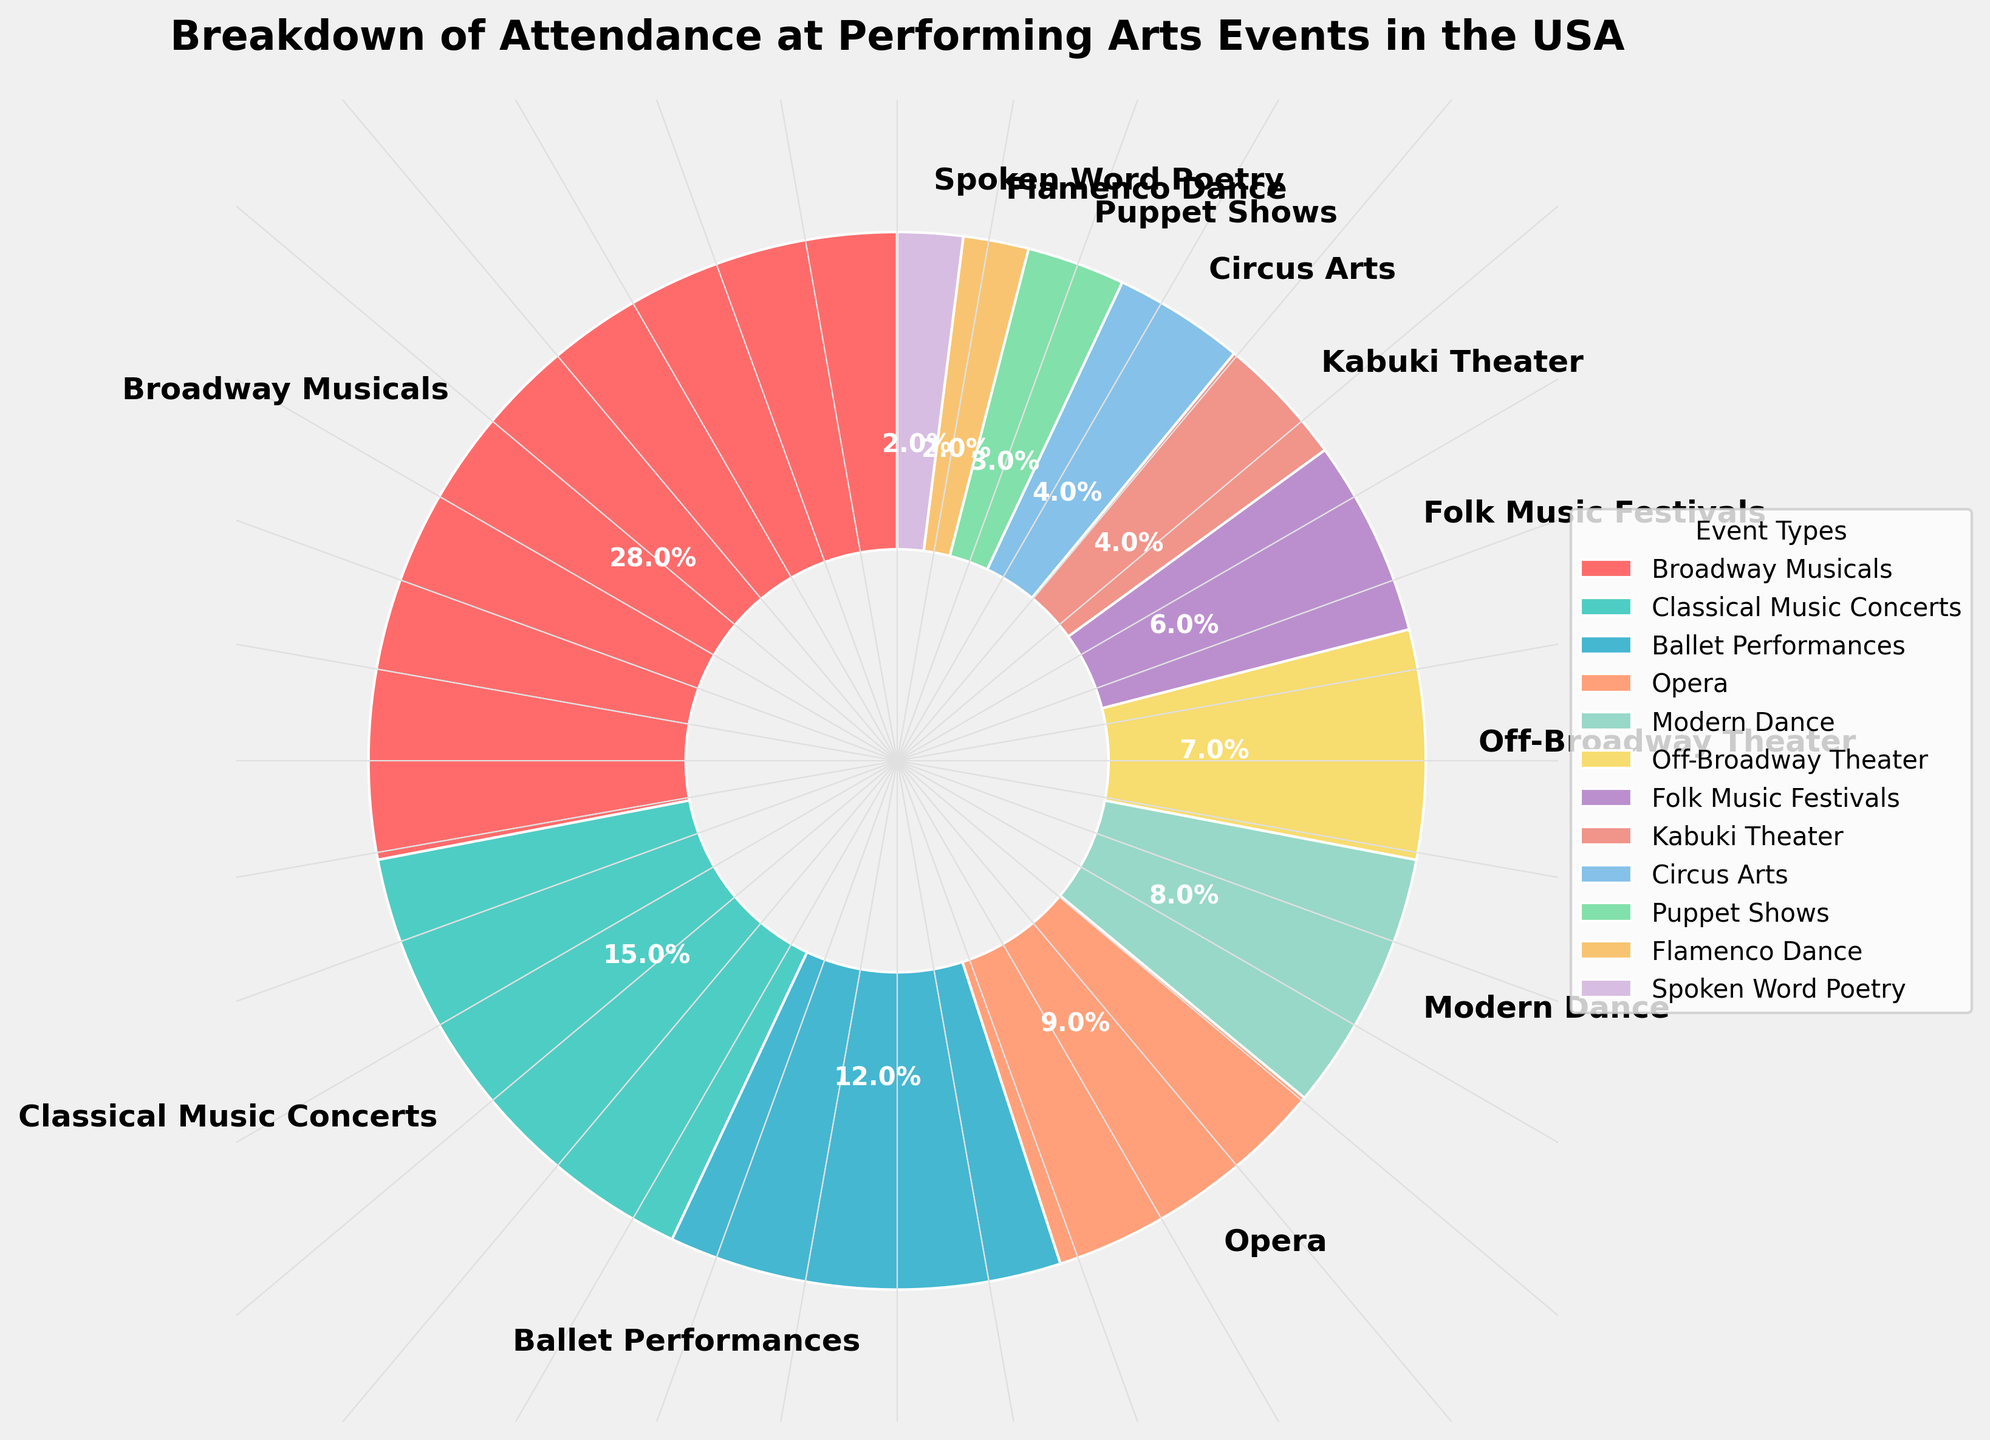Which event type has the highest attendance percentage? Look at the pie chart and identify the event type with the largest slice, which in this case is labeled "Broadway Musicals" with 28%.
Answer: Broadway Musicals Which events have an attendance percentage of less than 5%? Review the slices of the pie chart and identify the event types with attendance percentages labeled as 4% or below: Kabuki Theater, Circus Arts, Puppet Shows, Flamenco Dance, and Spoken Word Poetry.
Answer: Kabuki Theater, Circus Arts, Puppet Shows, Flamenco Dance, Spoken Word Poetry What is the sum of the attendance percentages for Classical Music Concerts and Ballet Performances? Find the slices labeled "Classical Music Concerts" (15%) and "Ballet Performances" (12%) and add their percentages: 15% + 12% = 27%.
Answer: 27% Which type of dance performance has a higher attendance percentage, Ballet Performances or Modern Dance? Compare the slices labeled "Ballet Performances" (12%) and "Modern Dance" (8%). Ballet Performances has a higher percentage.
Answer: Ballet Performances What is the difference in attendance percentage between Broadway Musicals and Opera? Find the slices labeled "Broadway Musicals" (28%) and "Opera" (9%). The difference is 28% - 9% = 19%.
Answer: 19% How many event types have an attendance percentage equal to or less than 4%? Identify the slices labeled with percentages equal to or less than 4%: Kabuki Theater, Circus Arts, Puppet Shows, Flamenco Dance, and Spoken Word Poetry, which add up to 5 event types.
Answer: 5 Which event type has an orange-colored slice in the pie chart? Look for the orange slice and then check its corresponding label, which is "Modern Dance".
Answer: Modern Dance What is the total attendance percentage for events with percentages greater than 10%? Identify the slices labeled with percentages greater than 10%: Broadway Musicals (28%), Classical Music Concerts (15%), and Ballet Performances (12%). Sum them up: 28% + 15% + 12% = 55%.
Answer: 55% Compare the combined attendance percentages of Off-Broadway Theater and Folk Music Festivals to the attendance percentage of Classical Music Concerts. Which is higher? Add the attendance percentages of Off-Broadway Theater (7%) and Folk Music Festivals (6%), getting 13%. Compare this to Classical Music Concerts (15%). The combined percentage is lower than Classical Music Concerts.
Answer: Classical Music Concerts What percentage of the total attendance at performing arts events is accounted for by events labeled with slices using green tones? Locate the green slices and identify their corresponding event types and percentages: Folk Music Festivals (6%) and Off-Broadway Theater (7%). Sum these percentages: 6% + 7% = 13%.
Answer: 13% 